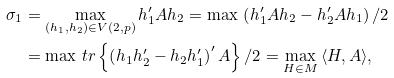<formula> <loc_0><loc_0><loc_500><loc_500>\sigma _ { 1 } & = \max _ { ( h _ { 1 } , h _ { 2 } ) \in V ( 2 , p ) } h _ { 1 } ^ { \prime } A h _ { 2 } = \max \, \left ( h _ { 1 } ^ { \prime } A h _ { 2 } - h _ { 2 } ^ { \prime } A h _ { 1 } \right ) / 2 \\ & = \max \, t r \left \{ \left ( h _ { 1 } h _ { 2 } ^ { \prime } - h _ { 2 } h _ { 1 } ^ { \prime } \right ) ^ { \prime } A \right \} / 2 = \max _ { H \in M } \, \langle H , A \rangle ,</formula> 